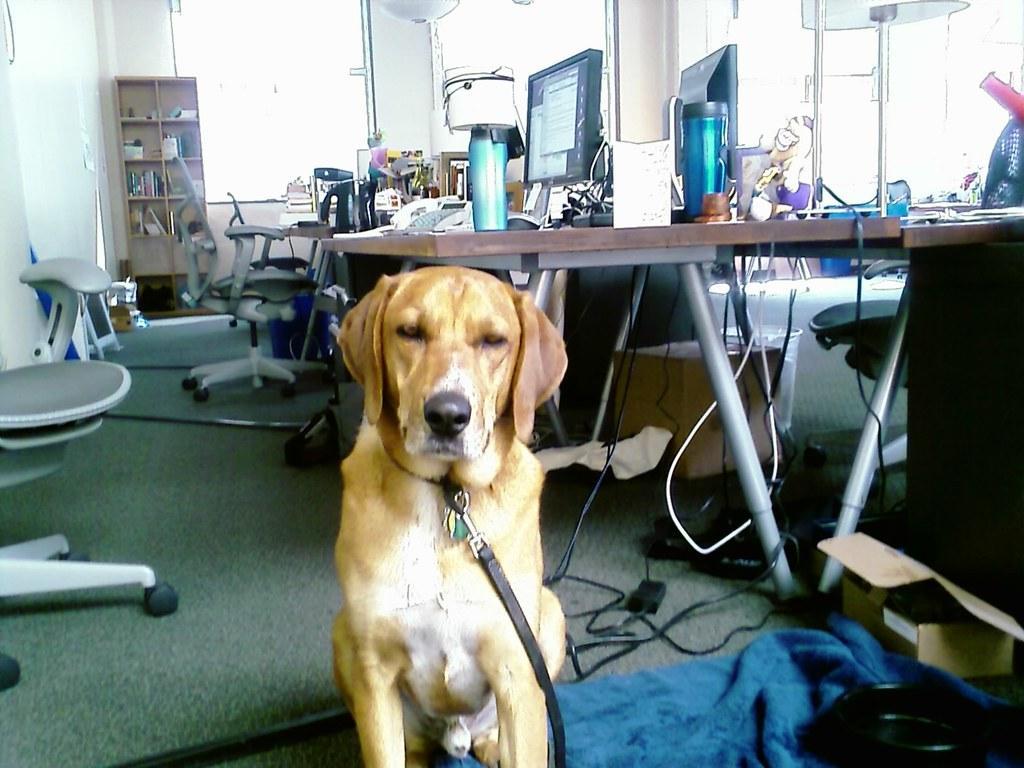How would you summarize this image in a sentence or two? In this image I see a dog which is of white and cream in color and I see the blue color cloth over here. In the background I see the disks on which there are 2 monitors, 2 bottles and many other things and I see the chairs and I see the rack over here on which there are few things and I see the wall and I see the wires over here. 